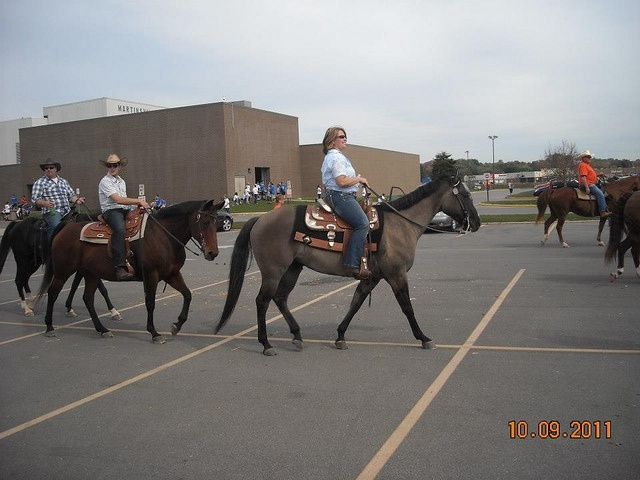Describe the objects in this image and their specific colors. I can see horse in darkgray, black, and gray tones, horse in darkgray, black, gray, and maroon tones, people in darkgray, gray, black, and lightgray tones, horse in darkgray, black, and gray tones, and people in darkgray, black, gray, and lightgray tones in this image. 